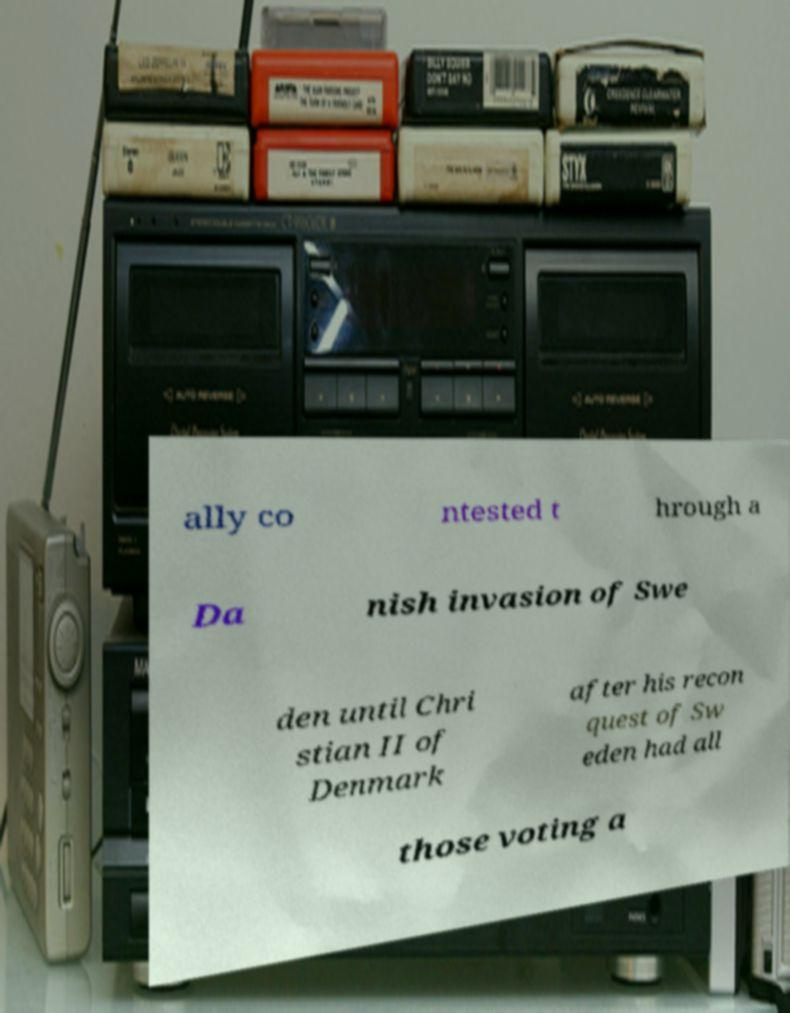Can you read and provide the text displayed in the image?This photo seems to have some interesting text. Can you extract and type it out for me? ally co ntested t hrough a Da nish invasion of Swe den until Chri stian II of Denmark after his recon quest of Sw eden had all those voting a 